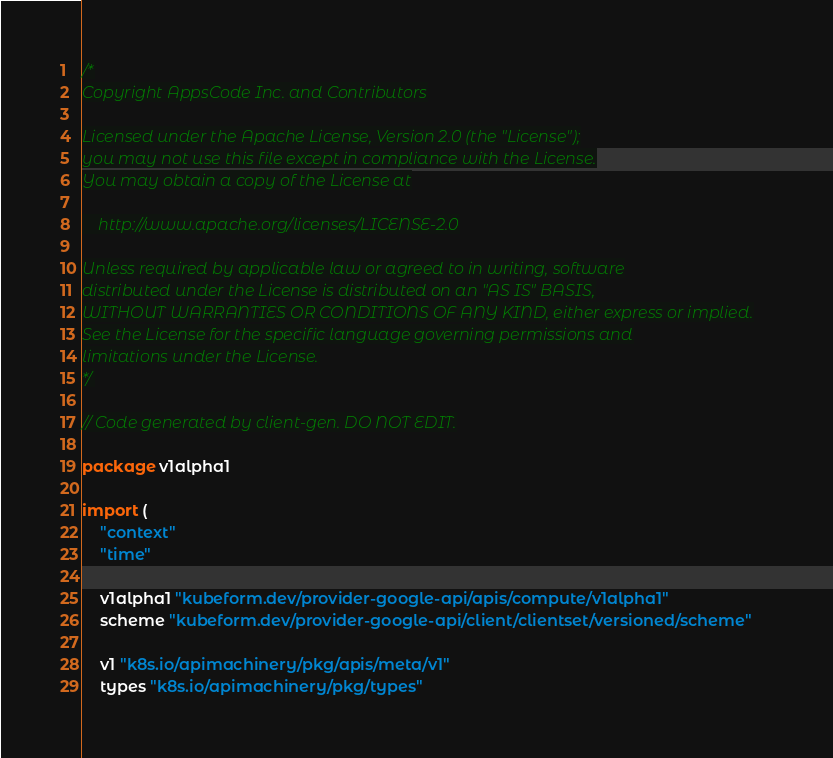Convert code to text. <code><loc_0><loc_0><loc_500><loc_500><_Go_>/*
Copyright AppsCode Inc. and Contributors

Licensed under the Apache License, Version 2.0 (the "License");
you may not use this file except in compliance with the License.
You may obtain a copy of the License at

    http://www.apache.org/licenses/LICENSE-2.0

Unless required by applicable law or agreed to in writing, software
distributed under the License is distributed on an "AS IS" BASIS,
WITHOUT WARRANTIES OR CONDITIONS OF ANY KIND, either express or implied.
See the License for the specific language governing permissions and
limitations under the License.
*/

// Code generated by client-gen. DO NOT EDIT.

package v1alpha1

import (
	"context"
	"time"

	v1alpha1 "kubeform.dev/provider-google-api/apis/compute/v1alpha1"
	scheme "kubeform.dev/provider-google-api/client/clientset/versioned/scheme"

	v1 "k8s.io/apimachinery/pkg/apis/meta/v1"
	types "k8s.io/apimachinery/pkg/types"</code> 